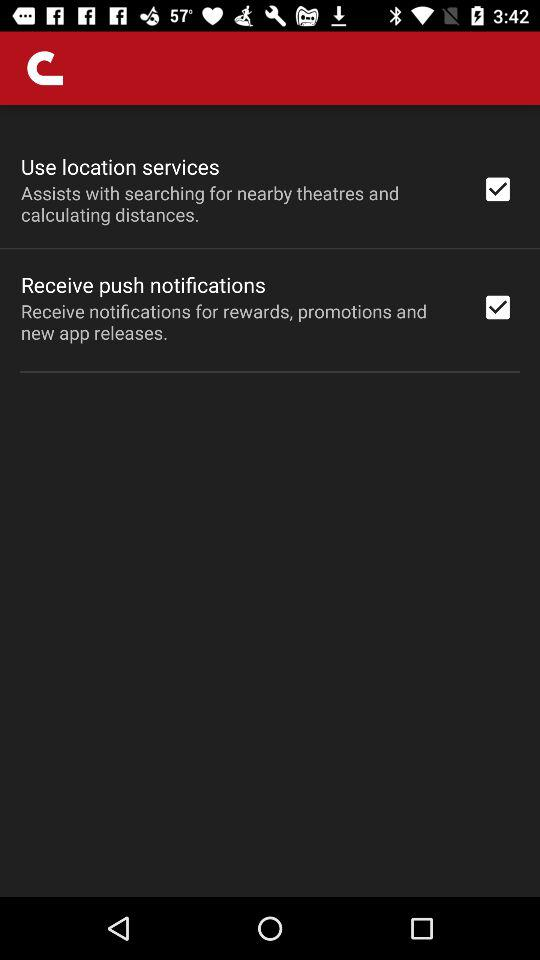Which options are marked as checked? The options are "Use location services" and "Receive push notifications". 